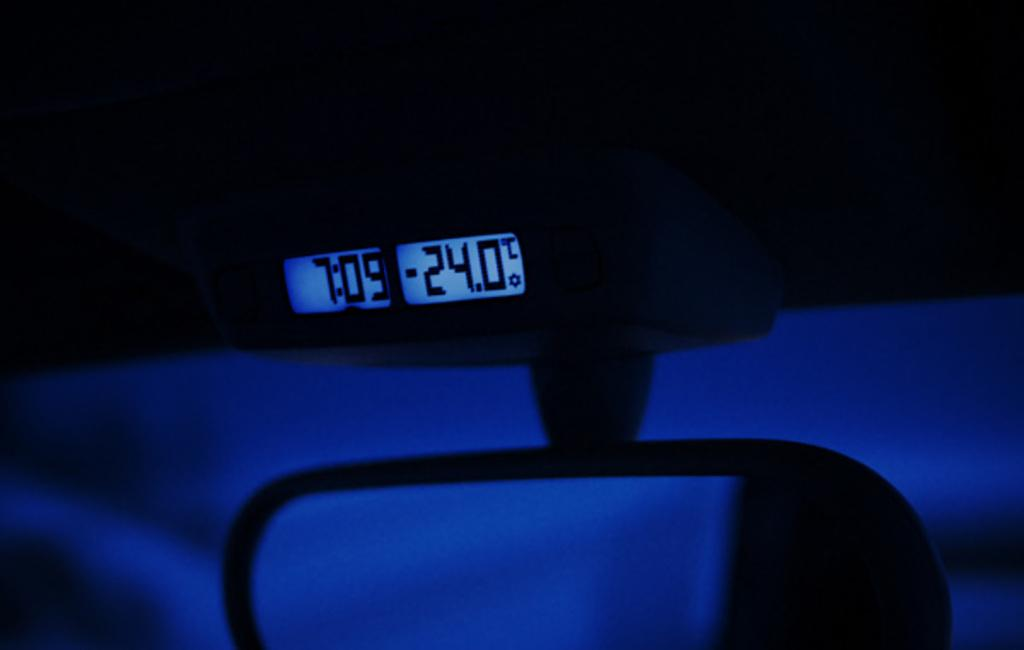What type of display is present in the image? There is a led display in the image. Can you describe the color of any objects in the image? There is a black and blue color object in the image. What is the mind of the object in the image? There is no indication of a mind or consciousness in the image, as it features an led display and a black and blue color object. 